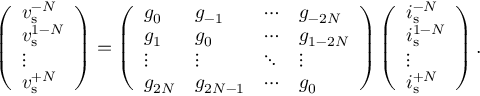<formula> <loc_0><loc_0><loc_500><loc_500>\left ( \begin{array} { l } { v _ { s } ^ { - N } } \\ { v _ { s } ^ { 1 - N } } \\ { \vdots } \\ { v _ { s } ^ { + N } } \end{array} \right ) = \left ( \begin{array} { l l l l } { g _ { 0 } } & { g _ { - 1 } } & { \cdots } & { g _ { - 2 N } } \\ { g _ { 1 } } & { g _ { 0 } } & { \cdots } & { g _ { 1 - 2 N } } \\ { \vdots } & { \vdots } & { \ddots } & { \vdots } \\ { g _ { 2 N } } & { g _ { 2 N - 1 } } & { \cdots } & { g _ { 0 } } \end{array} \right ) \left ( \begin{array} { l } { i _ { s } ^ { - N } } \\ { i _ { s } ^ { 1 - N } } \\ { \vdots } \\ { i _ { s } ^ { + N } } \end{array} \right ) .</formula> 